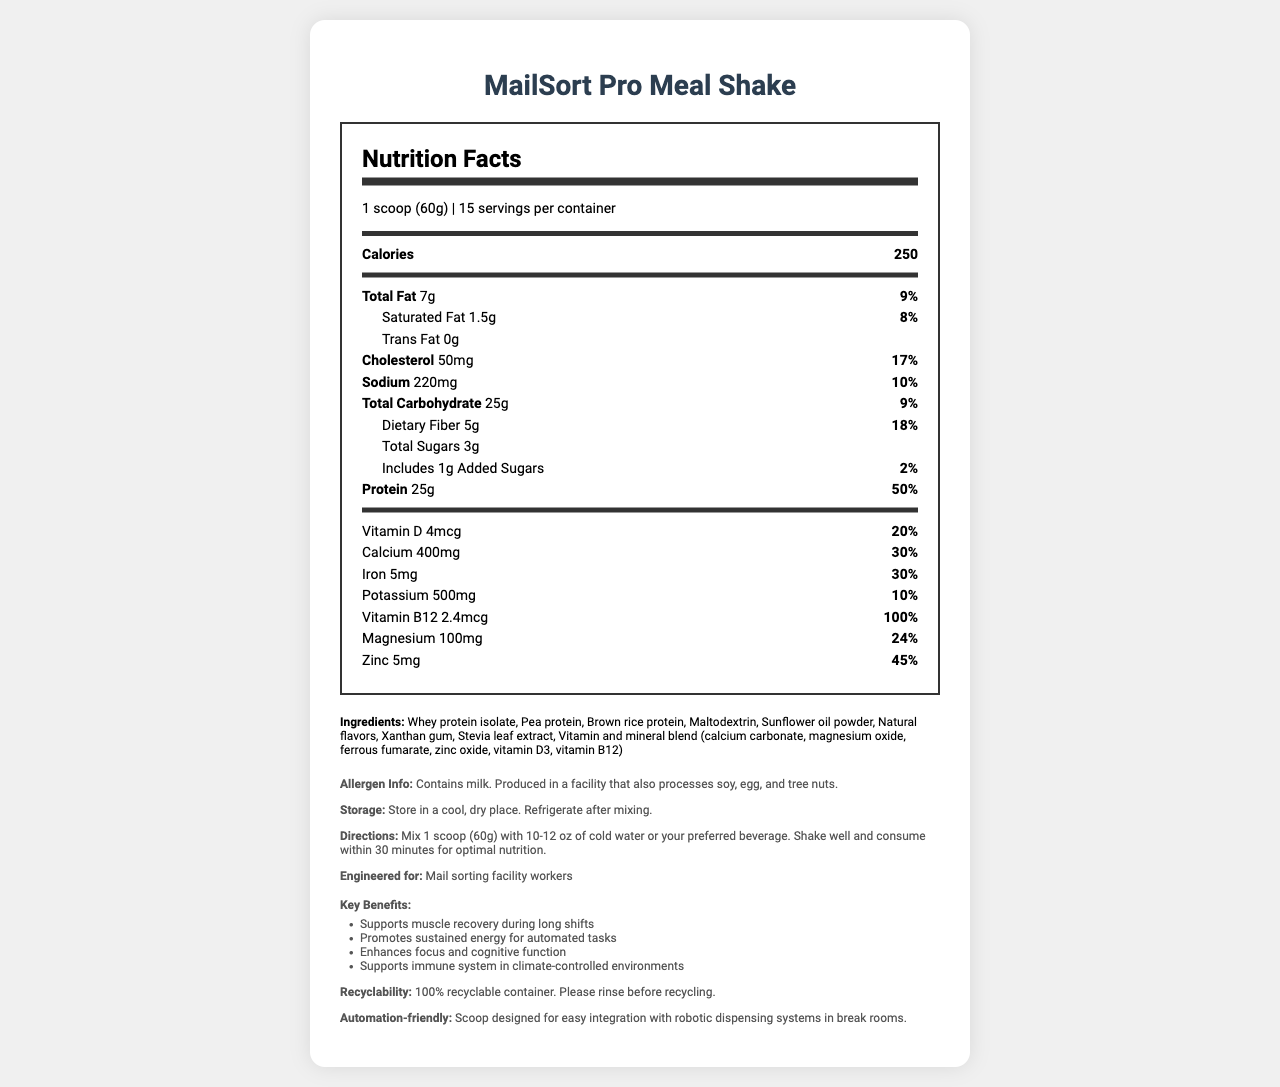what is the serving size? The document specifies the serving size as '1 scoop (60g)' in the serving information section.
Answer: 1 scoop (60g) how many calories are in one serving? The document lists 'Calories' as 250 for one serving on the nutrition label.
Answer: 250 what is the daily value percentage of protein per serving? The nutrition label indicates that the daily value percentage of protein is 50%.
Answer: 50% which ingredient is present first in the ingredient list? In the ingredients section, the first ingredient listed is 'Whey protein isolate'.
Answer: Whey protein isolate how much dietary fiber does one serving contain? The nutrition label states that one serving contains 5g of dietary fiber.
Answer: 5g what are the key benefits of MailSort Pro Meal Shake? The document lists these key benefits under the 'Key Benefits' section in the additional info section.
Answer: Supports muscle recovery during long shifts, Promotes sustained energy for automated tasks, Enhances focus and cognitive function, Supports immune system in climate-controlled environments how much iron does one serving provide? A. 5mg B. 10mg C. 15mg D. 20mg The nutrition label states that one serving provides 5mg of iron.
Answer: A. 5mg what percentage of daily value does magnesium constitute? I. 10% II. 15% III. 24% IV. 30% The document lists that the daily value percentage of magnesium is 24%.
Answer: III. 24% does MailSort Pro Meal Shake contain milk? The allergen information section states 'Contains milk'.
Answer: Yes summarize the main features of this document. The document highlights key nutritional data, ingredients, storage instructions, directions for usage, allergen information, and additional info including the engineered purpose and key benefits of the product. The shake is specifically tailored for workers in automated mail sorting facilities.
Answer: The document provides the nutrition facts, ingredients, and additional info for MailSort Pro Meal Shake. This high-protein meal replacement shake is designed for workers in automated mail sorting facilities. It includes benefits such as muscle recovery, sustained energy, cognitive function enhancement, and immune support. The container is 100% recyclable and designed for easy integration with robotic dispensing systems. what is the storage instruction for MailSort Pro Meal Shake? The storage instructions are mentioned in the additional info section.
Answer: Store in a cool, dry place. Refrigerate after mixing. is the container recyclable? The additional info section under 'Recyclability' states that the container is 100% recyclable.
Answer: Yes can the exact cost of MailSort Pro Meal Shake be determined from the information in the document? The document does not provide any information on the price or cost of the product.
Answer: Cannot be determined 